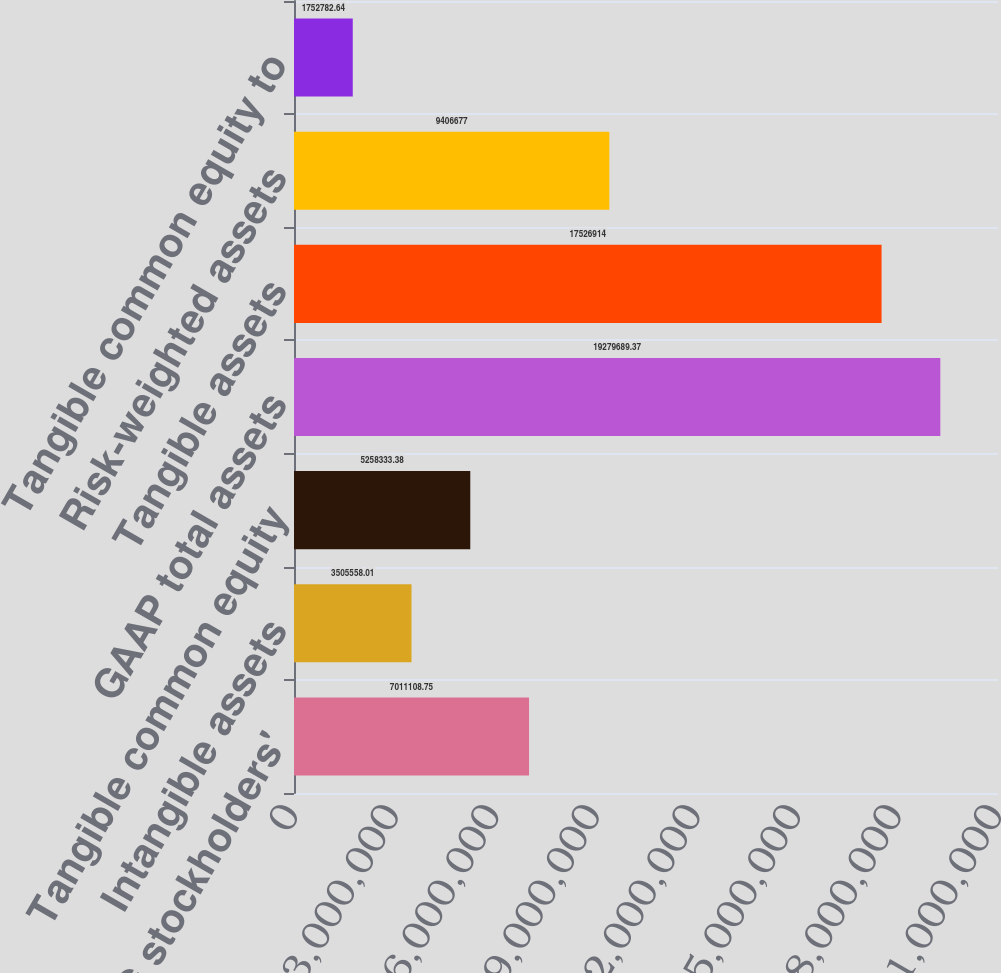Convert chart to OTSL. <chart><loc_0><loc_0><loc_500><loc_500><bar_chart><fcel>GAAP SVBFG stockholders'<fcel>Intangible assets<fcel>Tangible common equity<fcel>GAAP total assets<fcel>Tangible assets<fcel>Risk-weighted assets<fcel>Tangible common equity to<nl><fcel>7.01111e+06<fcel>3.50556e+06<fcel>5.25833e+06<fcel>1.92797e+07<fcel>1.75269e+07<fcel>9.40668e+06<fcel>1.75278e+06<nl></chart> 